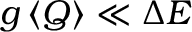<formula> <loc_0><loc_0><loc_500><loc_500>g \left \langle Q \right \rangle \ll \Delta E</formula> 